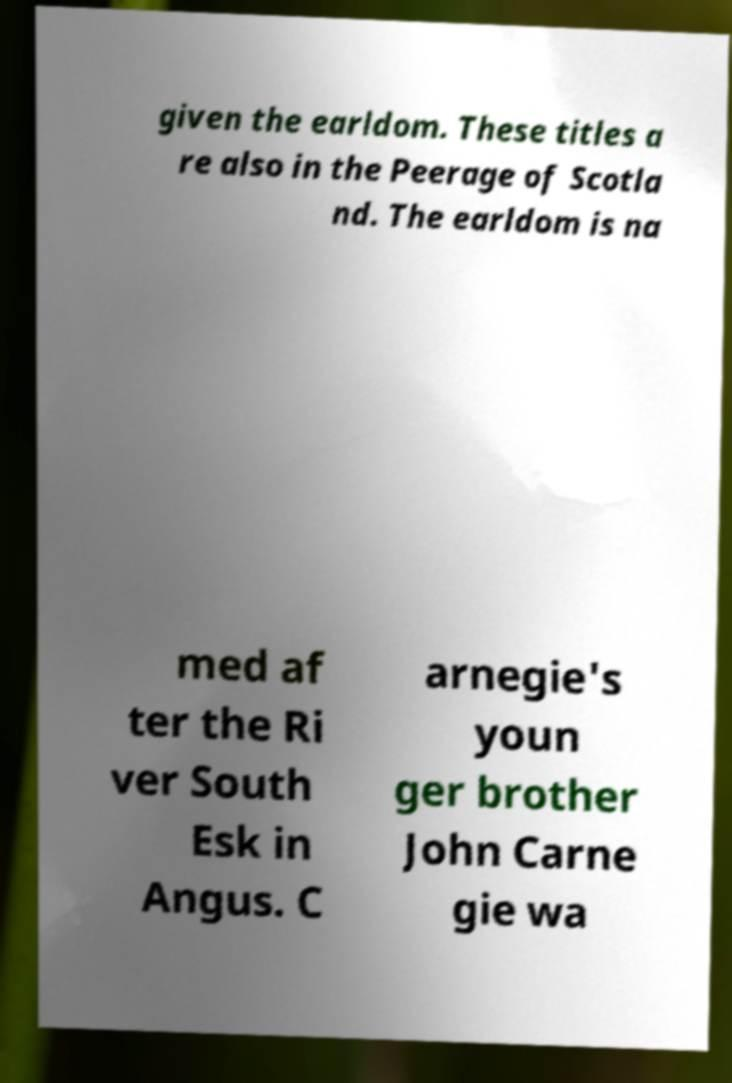Please identify and transcribe the text found in this image. given the earldom. These titles a re also in the Peerage of Scotla nd. The earldom is na med af ter the Ri ver South Esk in Angus. C arnegie's youn ger brother John Carne gie wa 